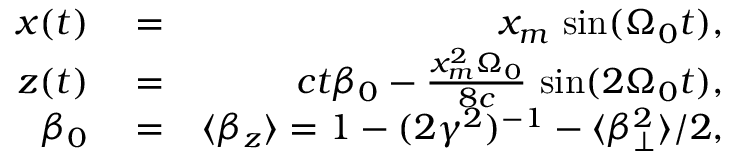<formula> <loc_0><loc_0><loc_500><loc_500>\begin{array} { r l r } { x ( t ) } & = } & { x _ { m } \, \sin ( \Omega _ { 0 } t ) , } \\ { z ( t ) } & = } & { c t \beta _ { 0 } - \frac { x _ { m } ^ { 2 } \Omega _ { 0 } } { 8 c } \, \sin ( 2 \Omega _ { 0 } t ) , } \\ { \beta _ { 0 } } & = } & { \langle \beta _ { z } \rangle = 1 - ( 2 \gamma ^ { 2 } ) ^ { - 1 } - \langle \beta _ { \perp } ^ { 2 } \rangle / 2 , } \end{array}</formula> 